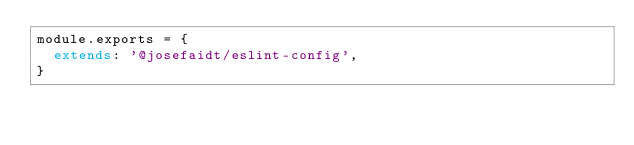Convert code to text. <code><loc_0><loc_0><loc_500><loc_500><_JavaScript_>module.exports = {
  extends: '@josefaidt/eslint-config',
}</code> 